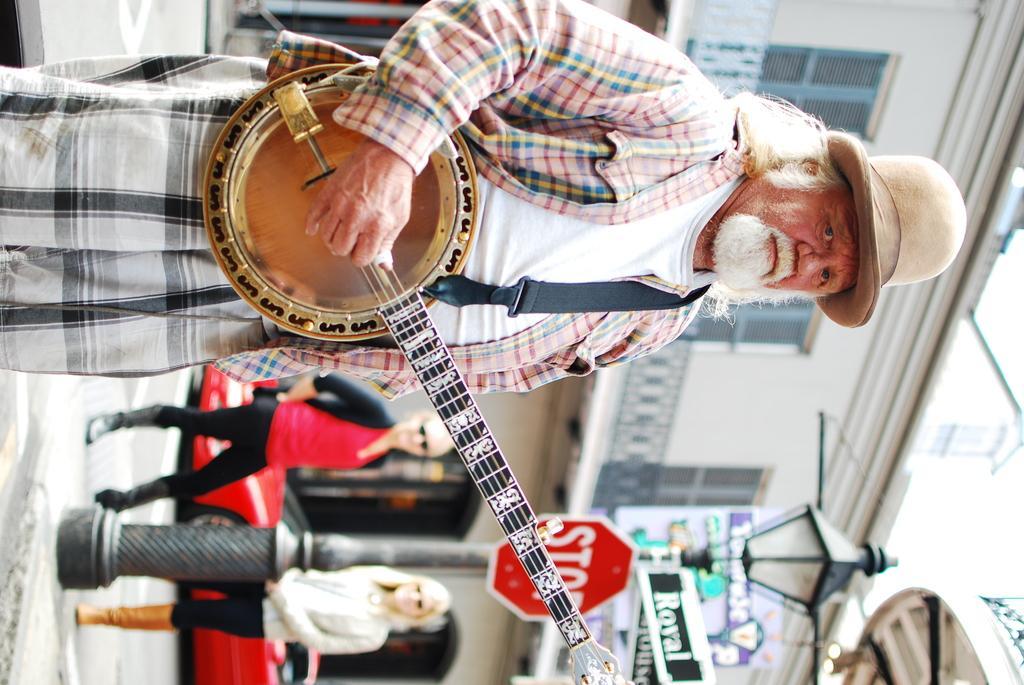Please provide a concise description of this image. In this image, we can see an old person playing a music instrument and wearing a hat. Background we can see building, vehicle, pole, sign boards, lights. Few people on the road. 